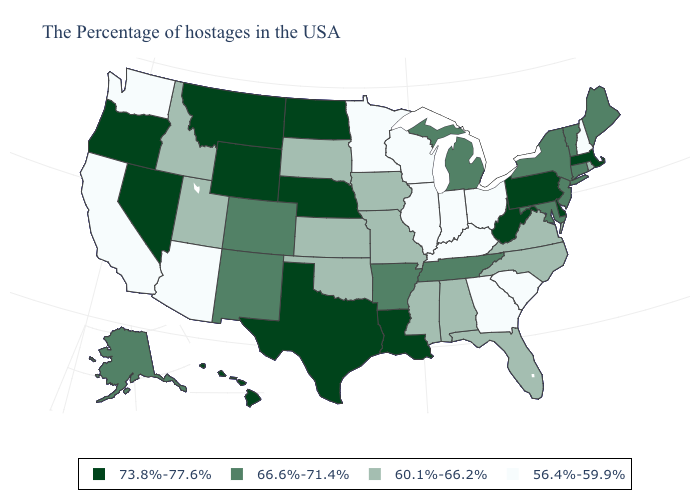Does the map have missing data?
Concise answer only. No. Among the states that border Vermont , which have the highest value?
Answer briefly. Massachusetts. Does Wisconsin have a higher value than Illinois?
Answer briefly. No. Name the states that have a value in the range 73.8%-77.6%?
Give a very brief answer. Massachusetts, Delaware, Pennsylvania, West Virginia, Louisiana, Nebraska, Texas, North Dakota, Wyoming, Montana, Nevada, Oregon, Hawaii. Among the states that border Michigan , which have the lowest value?
Quick response, please. Ohio, Indiana, Wisconsin. What is the highest value in states that border Wisconsin?
Concise answer only. 66.6%-71.4%. What is the highest value in the West ?
Quick response, please. 73.8%-77.6%. What is the value of New Mexico?
Concise answer only. 66.6%-71.4%. What is the highest value in the USA?
Answer briefly. 73.8%-77.6%. Which states have the lowest value in the USA?
Quick response, please. New Hampshire, South Carolina, Ohio, Georgia, Kentucky, Indiana, Wisconsin, Illinois, Minnesota, Arizona, California, Washington. Does Washington have the same value as Minnesota?
Write a very short answer. Yes. Does Rhode Island have the highest value in the USA?
Answer briefly. No. What is the lowest value in the West?
Quick response, please. 56.4%-59.9%. Name the states that have a value in the range 60.1%-66.2%?
Write a very short answer. Rhode Island, Virginia, North Carolina, Florida, Alabama, Mississippi, Missouri, Iowa, Kansas, Oklahoma, South Dakota, Utah, Idaho. Does North Dakota have the highest value in the MidWest?
Write a very short answer. Yes. 